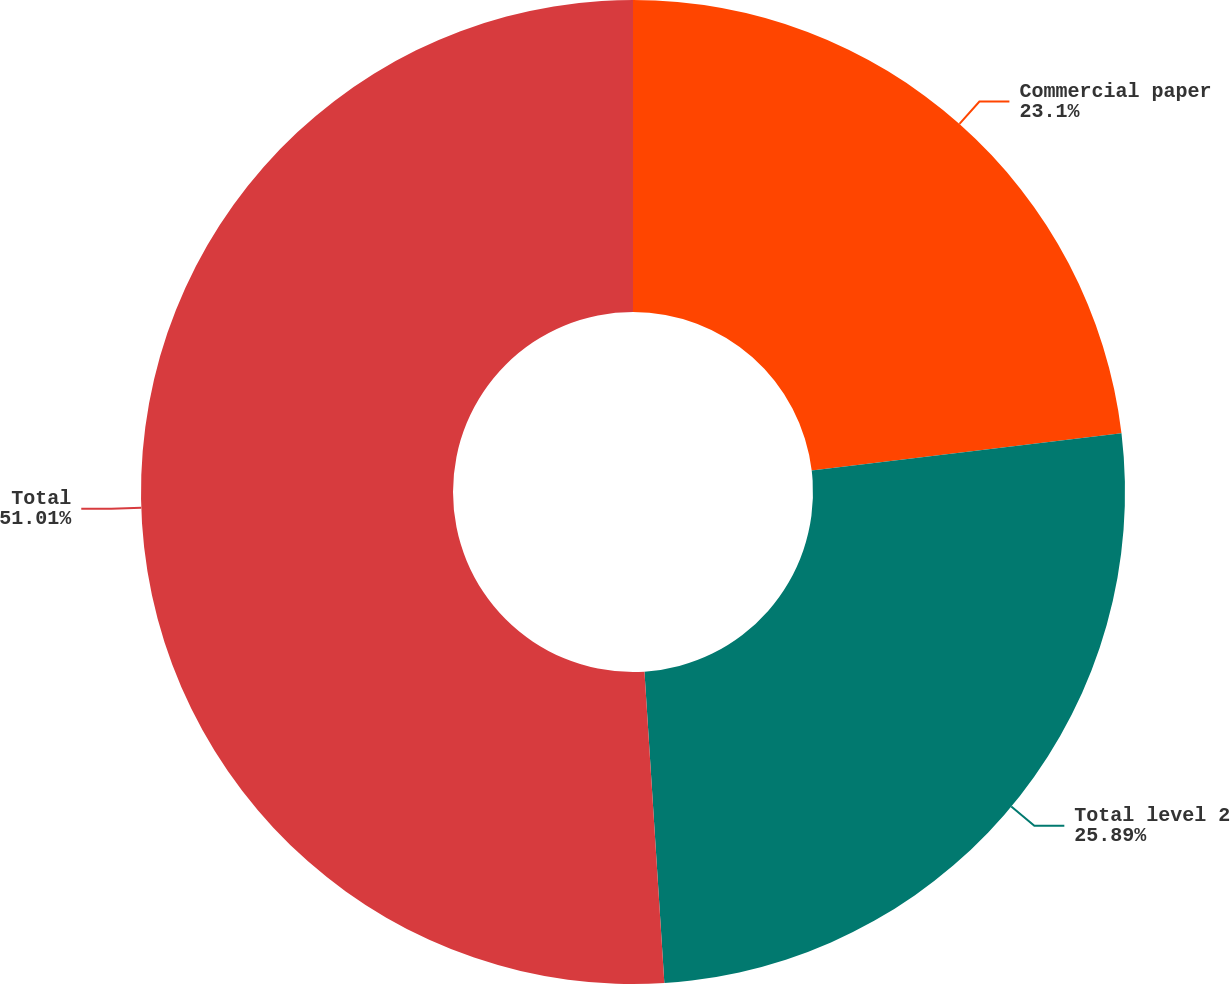<chart> <loc_0><loc_0><loc_500><loc_500><pie_chart><fcel>Commercial paper<fcel>Total level 2<fcel>Total<nl><fcel>23.1%<fcel>25.89%<fcel>51.02%<nl></chart> 